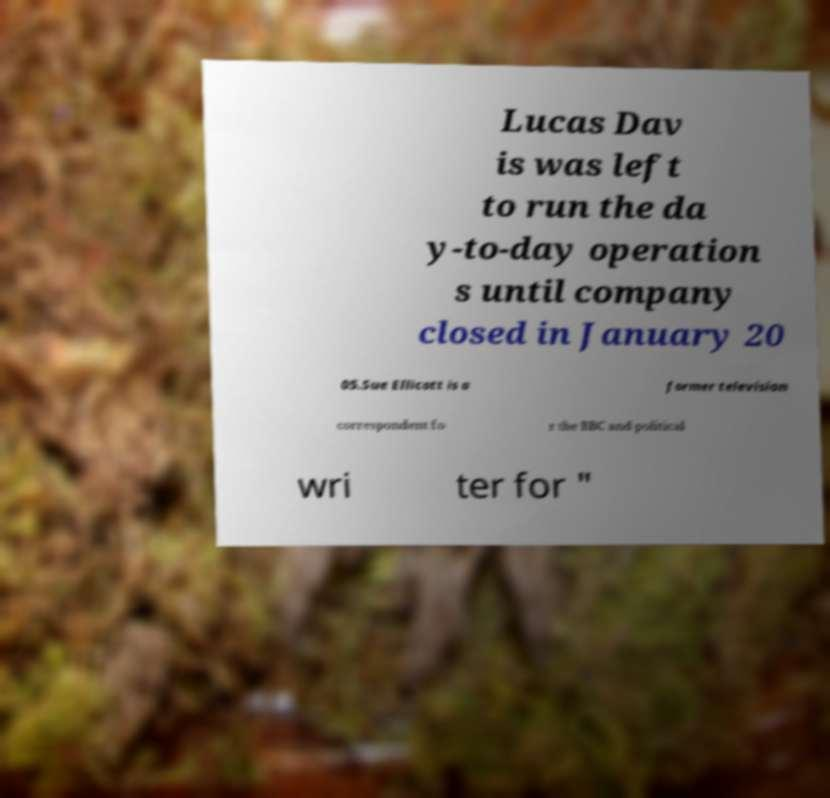Can you accurately transcribe the text from the provided image for me? Lucas Dav is was left to run the da y-to-day operation s until company closed in January 20 05.Sue Ellicott is a former television correspondent fo r the BBC and political wri ter for " 